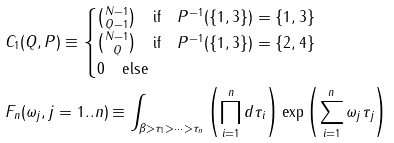Convert formula to latex. <formula><loc_0><loc_0><loc_500><loc_500>& C _ { 1 } ( Q , P ) \equiv \begin{cases} \binom { N - 1 } { Q - 1 } \quad \text {if} \quad P ^ { - 1 } ( \{ 1 , 3 \} ) = \{ 1 , 3 \} \\ \binom { N - 1 } { Q } \quad \text {if} \quad P ^ { - 1 } ( \{ 1 , 3 \} ) = \{ 2 , 4 \} \\ 0 \quad \text {else} \end{cases} \\ & F _ { n } ( \omega _ { j } , j = 1 . . n ) \equiv \int _ { \beta > \tau _ { 1 } > \dots > \tau _ { n } } \left ( \prod _ { i = 1 } ^ { n } d \tau _ { i } \right ) \exp \left ( \sum _ { i = 1 } ^ { n } \omega _ { j } \tau _ { j } \right )</formula> 